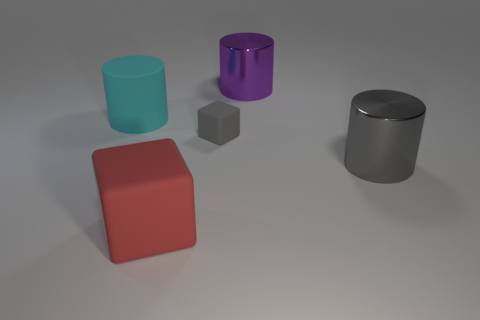Add 4 tiny matte cubes. How many objects exist? 9 Subtract all cylinders. How many objects are left? 2 Subtract all small yellow objects. Subtract all big cyan rubber objects. How many objects are left? 4 Add 1 tiny gray cubes. How many tiny gray cubes are left? 2 Add 2 large blue metal cylinders. How many large blue metal cylinders exist? 2 Subtract 0 brown cubes. How many objects are left? 5 